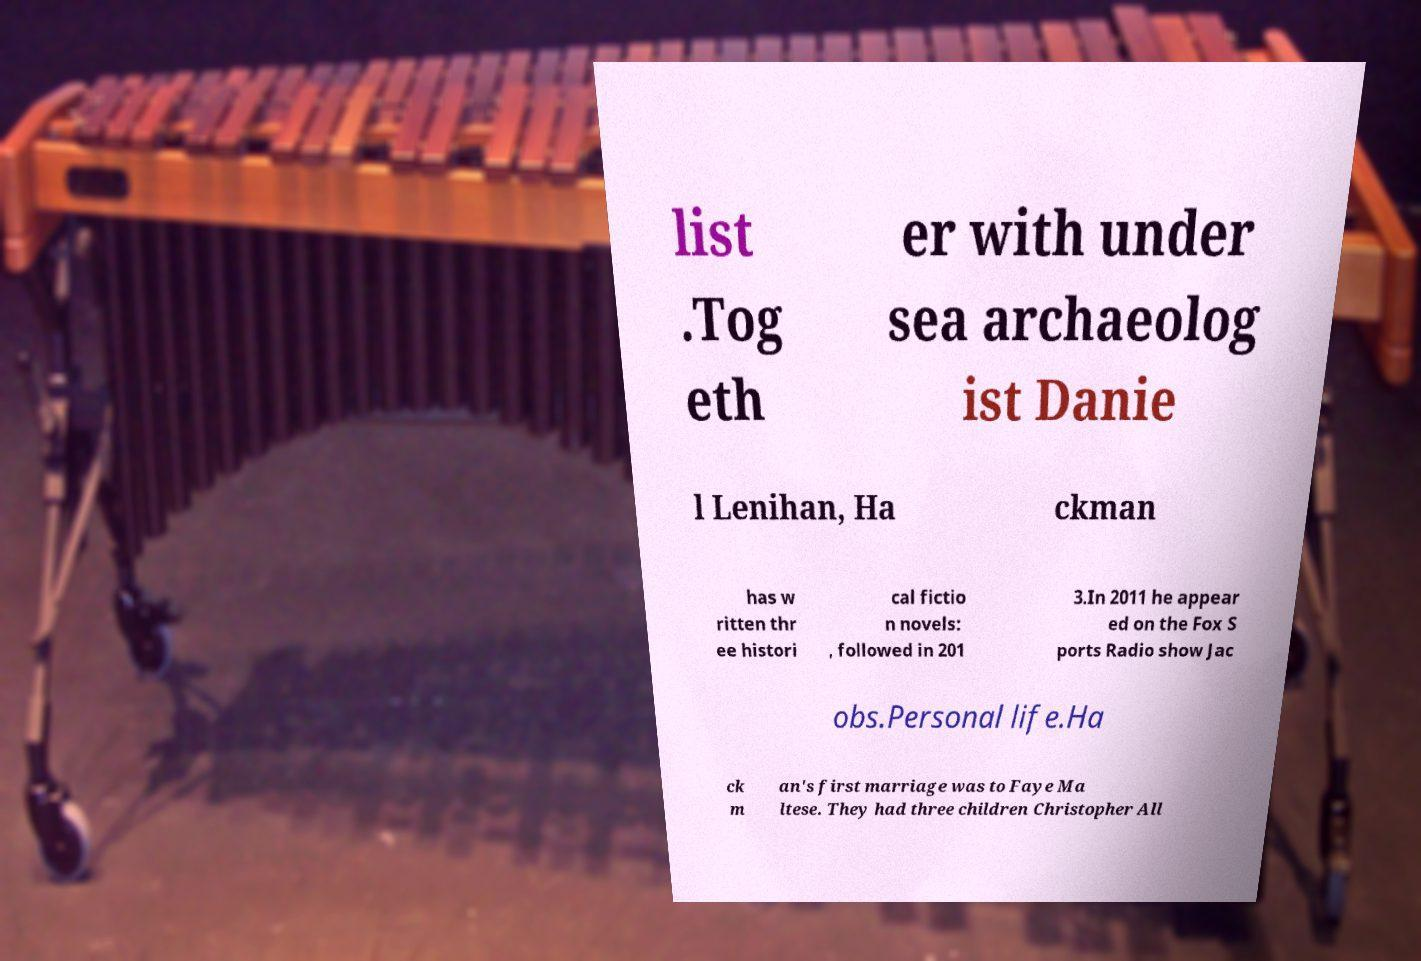Please identify and transcribe the text found in this image. list .Tog eth er with under sea archaeolog ist Danie l Lenihan, Ha ckman has w ritten thr ee histori cal fictio n novels: , followed in 201 3.In 2011 he appear ed on the Fox S ports Radio show Jac obs.Personal life.Ha ck m an's first marriage was to Faye Ma ltese. They had three children Christopher All 